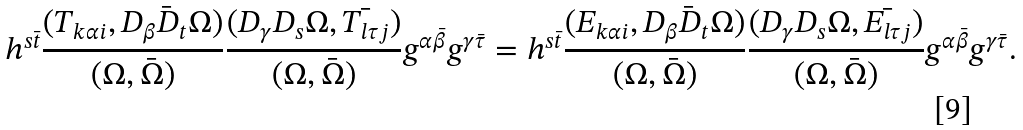Convert formula to latex. <formula><loc_0><loc_0><loc_500><loc_500>h ^ { s \bar { t } } \frac { ( T _ { k \alpha i } , \bar { D _ { \beta } D _ { t } \Omega } ) } { ( \Omega , \bar { \Omega } ) } \frac { ( D _ { \gamma } D _ { s } \Omega , \bar { T _ { l \tau j } } ) } { ( \Omega , \bar { \Omega } ) } g ^ { \alpha \bar { \beta } } g ^ { \gamma \bar { \tau } } = h ^ { s \bar { t } } \frac { ( E _ { k \alpha i } , \bar { D _ { \beta } D _ { t } \Omega } ) } { ( \Omega , \bar { \Omega } ) } \frac { ( D _ { \gamma } D _ { s } \Omega , \bar { E _ { l \tau j } } ) } { ( \Omega , \bar { \Omega } ) } g ^ { \alpha \bar { \beta } } g ^ { \gamma \bar { \tau } } .</formula> 